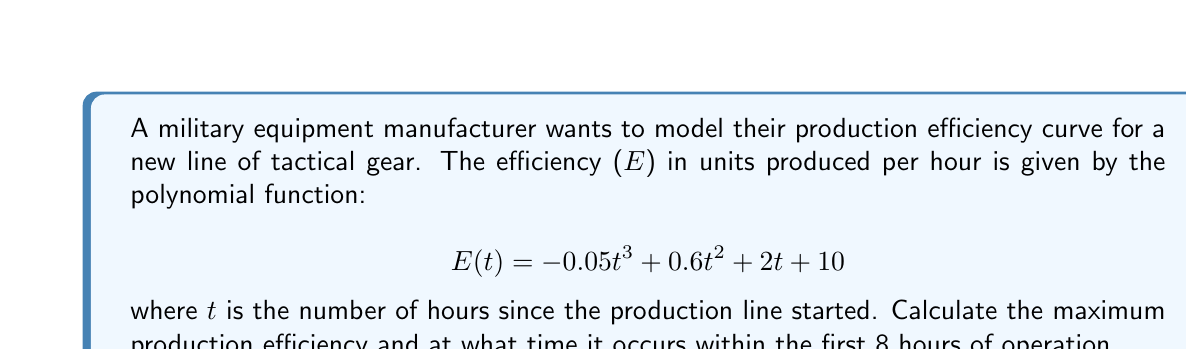Could you help me with this problem? To find the maximum production efficiency, we need to find the maximum value of the function E(t) within the given time range (0 ≤ t ≤ 8).

1. First, let's find the critical points by taking the derivative of E(t) and setting it equal to zero:

   $$E'(t) = -0.15t^2 + 1.2t + 2$$

   Set E'(t) = 0:
   $$-0.15t^2 + 1.2t + 2 = 0$$

2. Solve this quadratic equation:
   $$t = \frac{-1.2 \pm \sqrt{1.2^2 - 4(-0.15)(2)}}{2(-0.15)}$$
   $$t \approx 5.69 \text{ or } -2.35$$

3. Since we're only concerned with the first 8 hours (t ≥ 0), we only consider t ≈ 5.69.

4. To confirm this is a maximum, check the second derivative:
   $$E''(t) = -0.3t + 1.2$$
   $$E''(5.69) \approx -0.507 < 0$$
   This confirms t ≈ 5.69 gives a local maximum.

5. Calculate the maximum efficiency:
   $$E(5.69) = -0.05(5.69)^3 + 0.6(5.69)^2 + 2(5.69) + 10 \approx 24.76$$

Therefore, the maximum production efficiency occurs at approximately 5.69 hours after the start of production, with an efficiency of about 24.76 units per hour.
Answer: Maximum production efficiency: 24.76 units per hour
Time of maximum efficiency: 5.69 hours after production start 